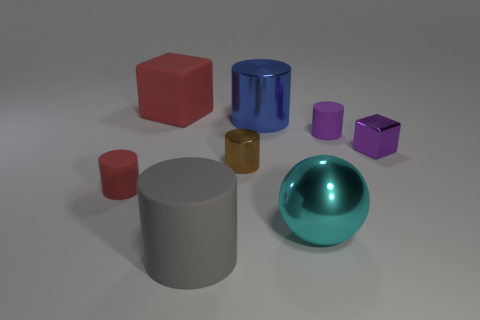Is the shape of the big cyan thing the same as the blue shiny thing?
Keep it short and to the point. No. There is a big cyan shiny thing; what number of blue metal things are to the right of it?
Provide a succinct answer. 0. What shape is the large matte thing that is behind the tiny rubber thing that is right of the large red matte thing?
Make the answer very short. Cube. What is the shape of the tiny brown object that is the same material as the cyan thing?
Give a very brief answer. Cylinder. There is a block right of the large blue cylinder; is its size the same as the matte cylinder in front of the metallic ball?
Your answer should be very brief. No. There is a small rubber thing that is in front of the small brown metal object; what is its shape?
Your answer should be compact. Cylinder. The ball has what color?
Your response must be concise. Cyan. Do the cyan thing and the cylinder in front of the tiny red cylinder have the same size?
Make the answer very short. Yes. What number of metal things are either large blue things or brown cylinders?
Provide a succinct answer. 2. Does the shiny cube have the same color as the tiny rubber cylinder that is in front of the brown metal object?
Your response must be concise. No. 